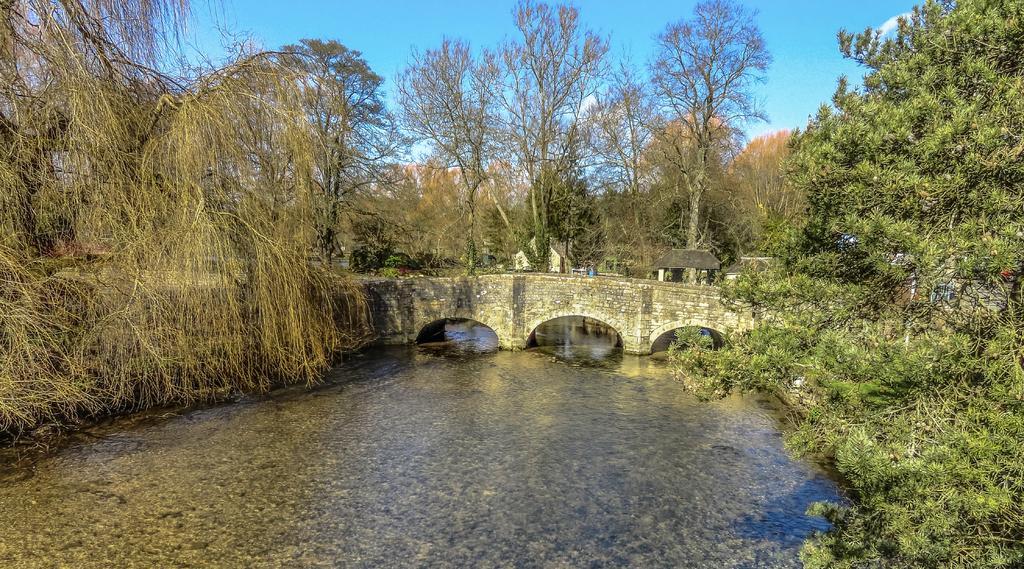Can you describe this image briefly? In this picture we can see water at the bottom, there is a bridge in the middle, we can see trees in the background, there is the sky at the top of the picture. 